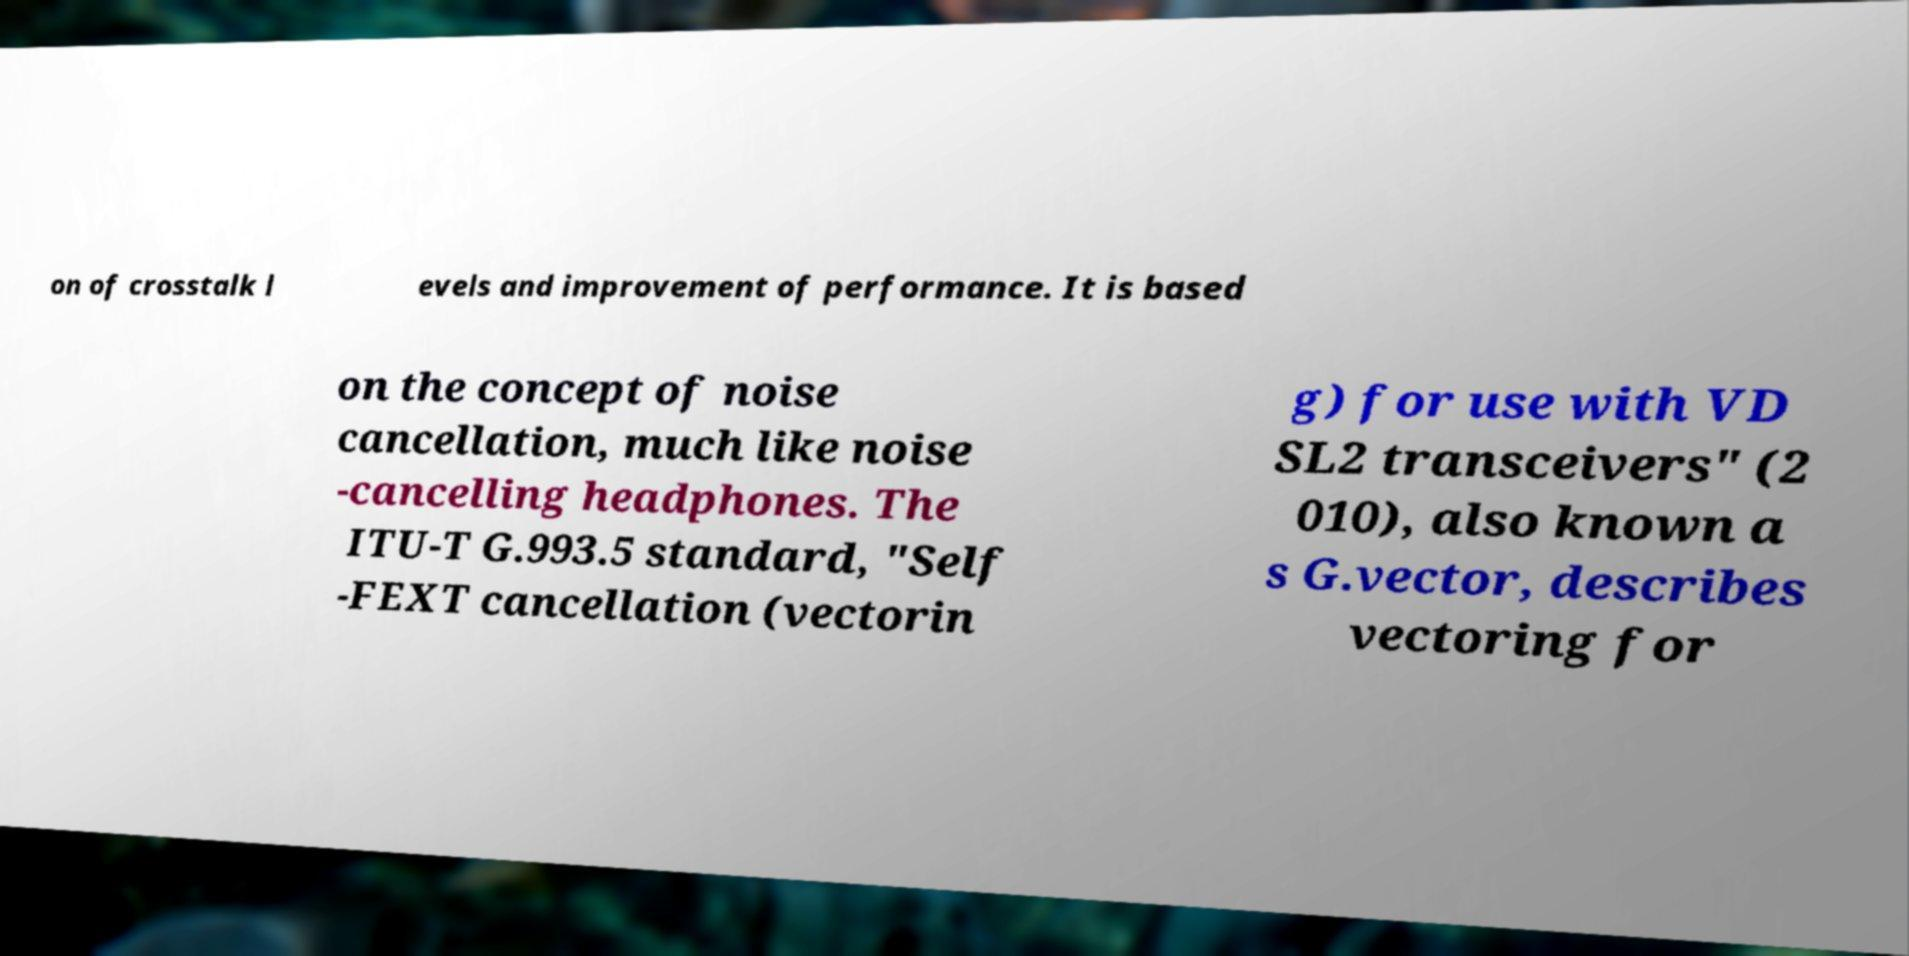I need the written content from this picture converted into text. Can you do that? on of crosstalk l evels and improvement of performance. It is based on the concept of noise cancellation, much like noise -cancelling headphones. The ITU-T G.993.5 standard, "Self -FEXT cancellation (vectorin g) for use with VD SL2 transceivers" (2 010), also known a s G.vector, describes vectoring for 